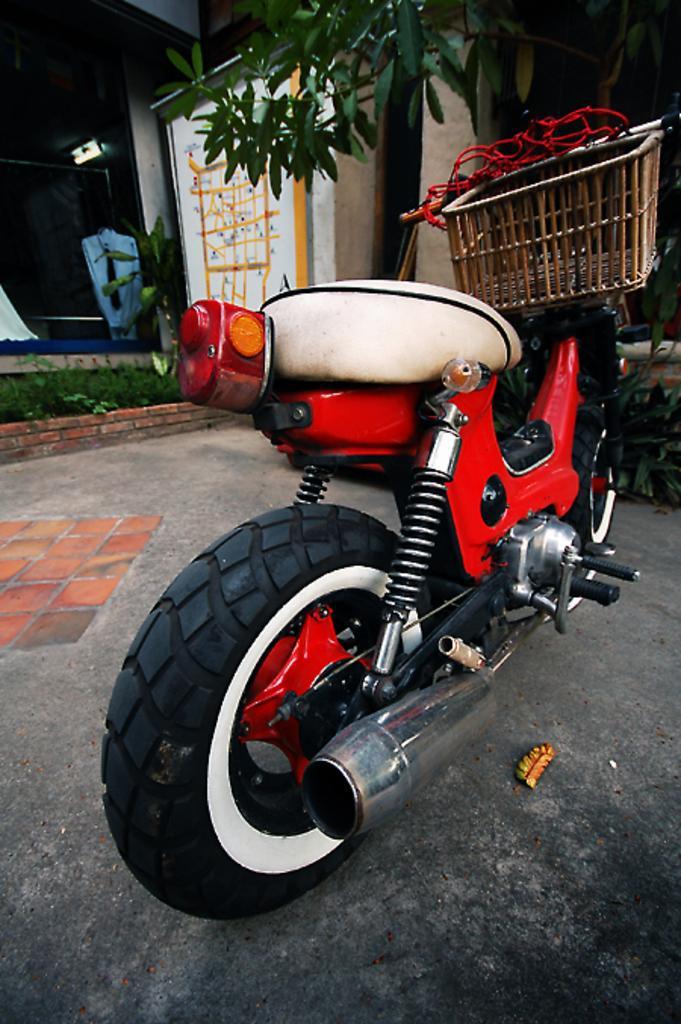Could you give a brief overview of what you see in this image? In the center of the image there is a vehicle on the road. In the background of the image there is a house. There is a tree. 